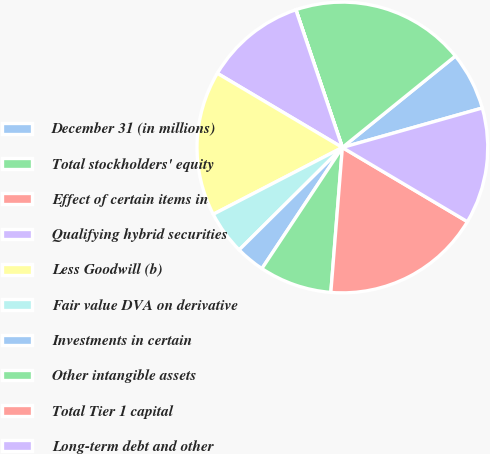<chart> <loc_0><loc_0><loc_500><loc_500><pie_chart><fcel>December 31 (in millions)<fcel>Total stockholders' equity<fcel>Effect of certain items in<fcel>Qualifying hybrid securities<fcel>Less Goodwill (b)<fcel>Fair value DVA on derivative<fcel>Investments in certain<fcel>Other intangible assets<fcel>Total Tier 1 capital<fcel>Long-term debt and other<nl><fcel>6.45%<fcel>19.35%<fcel>0.01%<fcel>11.29%<fcel>16.12%<fcel>4.84%<fcel>3.23%<fcel>8.07%<fcel>17.74%<fcel>12.9%<nl></chart> 